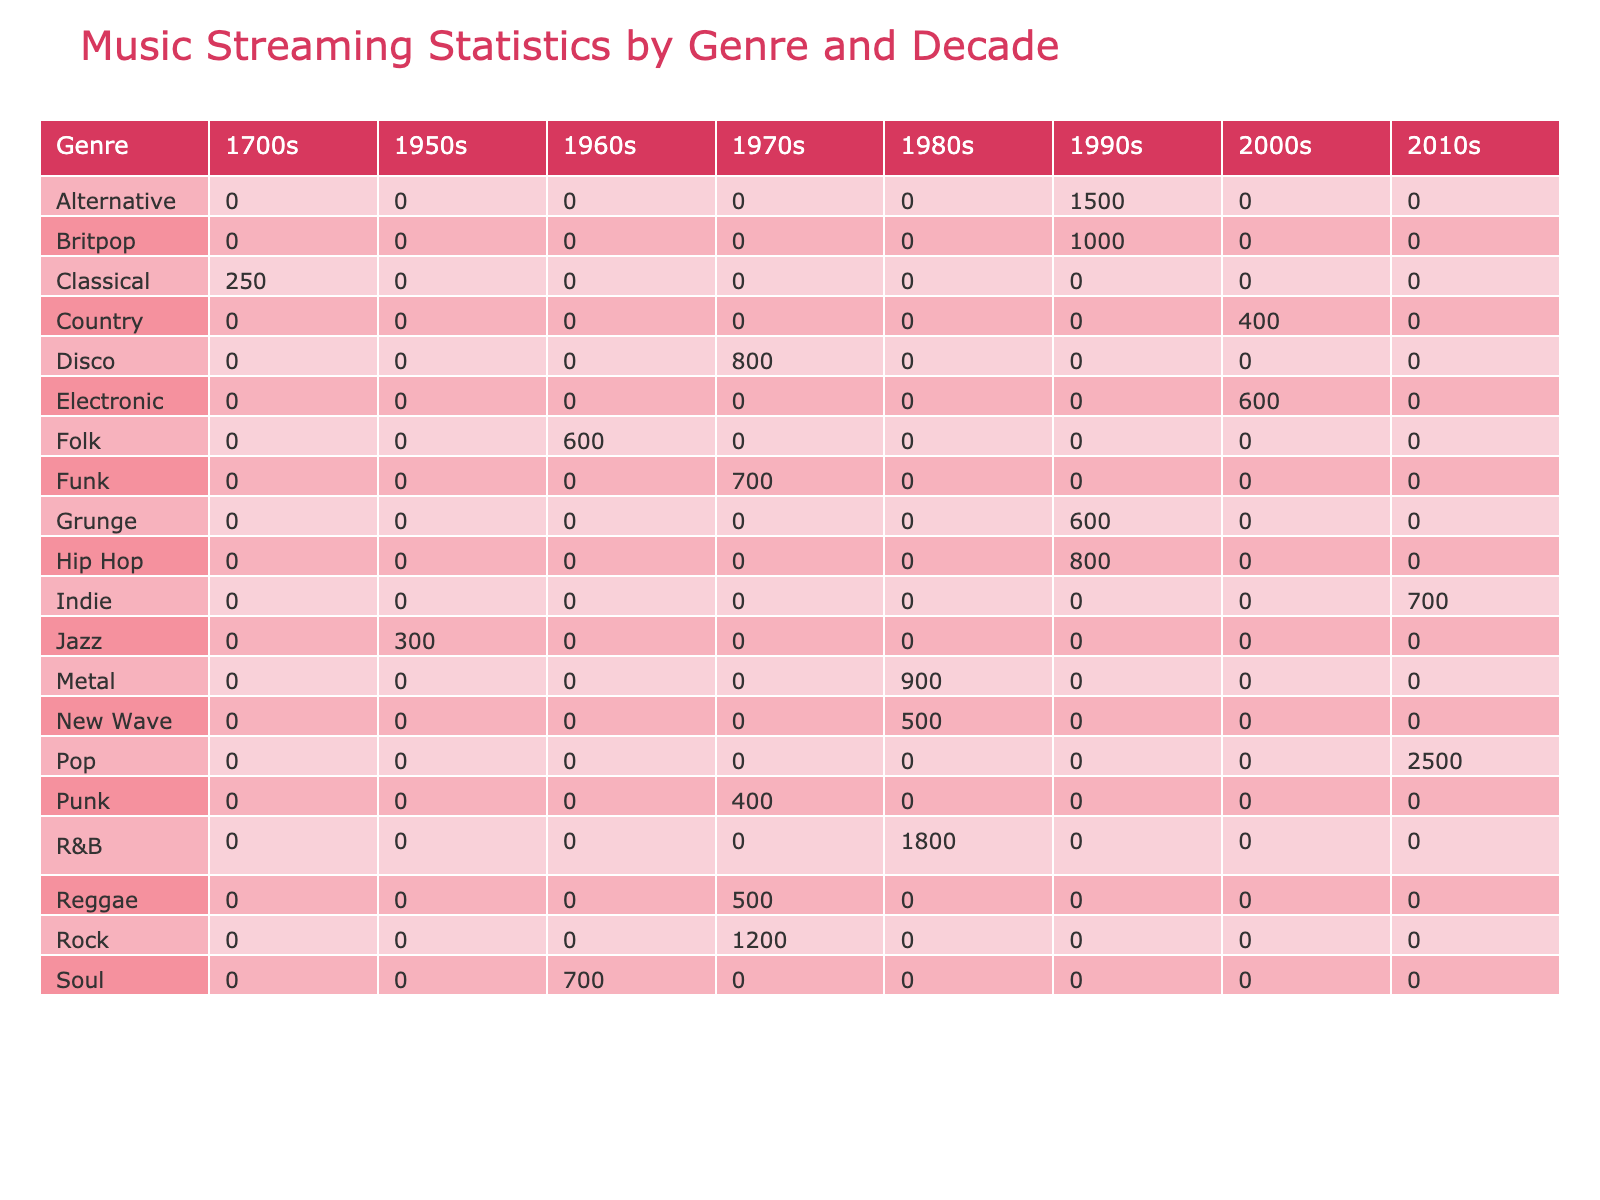What is the total number of streams for Rock music from the 1970s? The table shows that the only Rock song from the 1970s is "Stairway to Heaven" with 1200 million streams. Therefore, the total number of streams for Rock music from the 1970s is just the value for this song: 1200 million.
Answer: 1200 million Which genre had the highest average daily listens in the 2010s? By reviewing the average daily listens for each genre in the 2010s, Taylor Swift's "Shake It Off" has 300,000 listens, while Arctic Monkeys' "Do I Wanna Know?" has 85,000 listens. Since 300,000 is greater than 85,000, Pop is the genre with the highest average daily listens in the 2010s.
Answer: Pop What is the combined total of streams for Electronic and R&B in the 2000s? In the table, Daft Punk's "One More Time" in the Electronic genre has 600 million streams and Carrie Underwood's "Before He Cheats" in the R&B genre has 1800 million streams. Hence, the combined total streams are 600 + 1800 = 2400 million.
Answer: 2400 million Did any song from the 1980s achieve a user rating higher than 4.8? Looking at the user ratings for the songs in the 1980s, Metallica's "Enter Sandman" has a rating of 4.6, Depeche Mode's "Enjoy the Silence" has 4.6, and Michael Jackson's "Billie Jean" has 4.9. Since there is at least one song, Billie Jean, that has a rating higher than 4.8, the answer is yes.
Answer: Yes What is the difference in total streams between the highest and lowest streamed genre in the 1970s? In the 1970s, the highest streamed genre is Rock with 1200 million streams for "Stairway to Heaven," while the lowest streamed genre is Punk, which has 400 million streams for "Blitzkrieg Bop." The difference in total streams is 1200 - 400 = 800 million.
Answer: 800 million Which genre in the 1990s had more streams: Alternative or Hip Hop? The table indicates that Alternative music (Nirvana's "Smells Like Teen Spirit") has 1500 million streams, while Hip Hop (Tupac's "California Love") has 800 million streams. Comparing these values, the Alternative genre clearly exceeds Hip Hop in streams.
Answer: Alternative Was there a genre in the 1960s that managed to reach 700 million streams? In the 1960s, the genres recorded are Folk with 600 million streams ("Like a Rolling Stone") and Soul with 700 million streams ("Respect"). Since Soul achieved exactly 700 million streams, we can conclude that there was indeed a genre that reached this total.
Answer: Yes What is the average user rating for songs in the 2000s? First, we find the user ratings for the songs from the 2000s, which are: 4.6 (Electronic), 4.3 (Country), and 4.5 (Pop). To find the average, we will sum these ratings: 4.6 + 4.3 + 4.5 = 13.4, and divide by the number of items, which is 3, so 13.4 / 3 = approximately 4.47.
Answer: 4.47 How many genres had songs with a user rating of 4.9? Looking at the user ratings, we see that there are two songs with a user rating of 4.9: "Billie Jean" (R&B) and "Eine kleine Nachtmusik" (Classical). Therefore, there are two distinct genres that have achieved this rating.
Answer: 2 